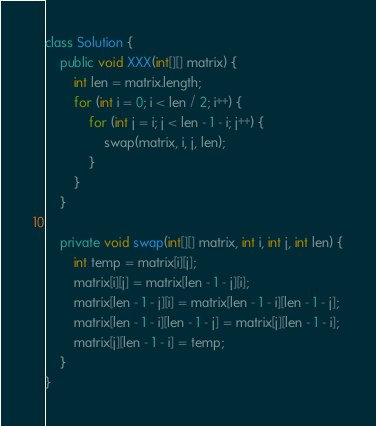<code> <loc_0><loc_0><loc_500><loc_500><_Java_>class Solution {
    public void XXX(int[][] matrix) {
        int len = matrix.length;
        for (int i = 0; i < len / 2; i++) {
            for (int j = i; j < len - 1 - i; j++) {
                swap(matrix, i, j, len);
            }
        }
    }

    private void swap(int[][] matrix, int i, int j, int len) {
        int temp = matrix[i][j];
        matrix[i][j] = matrix[len - 1 - j][i];
        matrix[len - 1 - j][i] = matrix[len - 1 - i][len - 1 - j];
        matrix[len - 1 - i][len - 1 - j] = matrix[j][len - 1 - i];
        matrix[j][len - 1 - i] = temp;
    }
}

</code> 